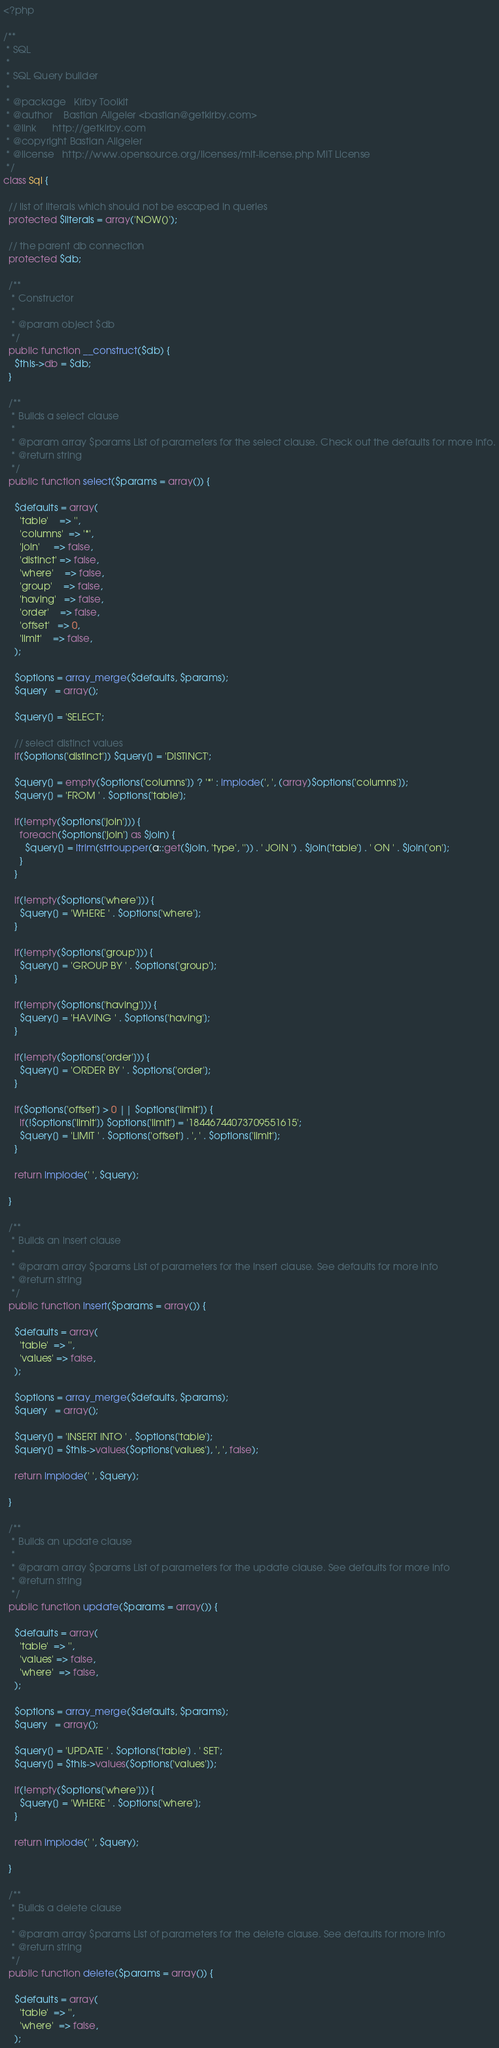<code> <loc_0><loc_0><loc_500><loc_500><_PHP_><?php

/**
 * SQL
 *
 * SQL Query builder
 *
 * @package   Kirby Toolkit
 * @author    Bastian Allgeier <bastian@getkirby.com>
 * @link      http://getkirby.com
 * @copyright Bastian Allgeier
 * @license   http://www.opensource.org/licenses/mit-license.php MIT License
 */
class Sql {

  // list of literals which should not be escaped in queries
  protected $literals = array('NOW()');

  // the parent db connection
  protected $db;

  /**
   * Constructor
   *
   * @param object $db
   */
  public function __construct($db) {
    $this->db = $db;
  }

  /**
   * Builds a select clause
   *
   * @param array $params List of parameters for the select clause. Check out the defaults for more info.
   * @return string
   */
  public function select($params = array()) {

    $defaults = array(
      'table'    => '',
      'columns'  => '*',
      'join'     => false,
      'distinct' => false,
      'where'    => false,
      'group'    => false,
      'having'   => false,
      'order'    => false,
      'offset'   => 0,
      'limit'    => false,
    );

    $options = array_merge($defaults, $params);
    $query   = array();

    $query[] = 'SELECT';

    // select distinct values
    if($options['distinct']) $query[] = 'DISTINCT';

    $query[] = empty($options['columns']) ? '*' : implode(', ', (array)$options['columns']);
    $query[] = 'FROM ' . $options['table'];

    if(!empty($options['join'])) {
      foreach($options['join'] as $join) {
        $query[] = ltrim(strtoupper(a::get($join, 'type', '')) . ' JOIN ') . $join['table'] . ' ON ' . $join['on'];
      }
    }

    if(!empty($options['where'])) {
      $query[] = 'WHERE ' . $options['where'];
    }

    if(!empty($options['group'])) {
      $query[] = 'GROUP BY ' . $options['group'];
    }

    if(!empty($options['having'])) {
      $query[] = 'HAVING ' . $options['having'];
    }

    if(!empty($options['order'])) {
      $query[] = 'ORDER BY ' . $options['order'];
    }

    if($options['offset'] > 0 || $options['limit']) {
      if(!$options['limit']) $options['limit'] = '18446744073709551615';
      $query[] = 'LIMIT ' . $options['offset'] . ', ' . $options['limit'];
    }

    return implode(' ', $query);

  }

  /**
   * Builds an insert clause
   *
   * @param array $params List of parameters for the insert clause. See defaults for more info
   * @return string
   */
  public function insert($params = array()) {

    $defaults = array(
      'table'  => '',
      'values' => false,
    );

    $options = array_merge($defaults, $params);
    $query   = array();

    $query[] = 'INSERT INTO ' . $options['table'];
    $query[] = $this->values($options['values'], ', ', false);

    return implode(' ', $query);

  }

  /**
   * Builds an update clause
   *
   * @param array $params List of parameters for the update clause. See defaults for more info
   * @return string
   */
  public function update($params = array()) {

    $defaults = array(
      'table'  => '',
      'values' => false,
      'where'  => false,
    );

    $options = array_merge($defaults, $params);
    $query   = array();

    $query[] = 'UPDATE ' . $options['table'] . ' SET';
    $query[] = $this->values($options['values']);

    if(!empty($options['where'])) {
      $query[] = 'WHERE ' . $options['where'];
    }

    return implode(' ', $query);

  }

  /**
   * Builds a delete clause
   *
   * @param array $params List of parameters for the delete clause. See defaults for more info
   * @return string
   */
  public function delete($params = array()) {

    $defaults = array(
      'table'  => '',
      'where'  => false,
    );
</code> 